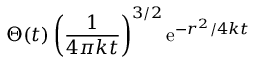Convert formula to latex. <formula><loc_0><loc_0><loc_500><loc_500>\Theta ( t ) \left ( { \frac { 1 } { 4 \pi k t } } \right ) ^ { 3 / 2 } e ^ { - r ^ { 2 } / 4 k t }</formula> 